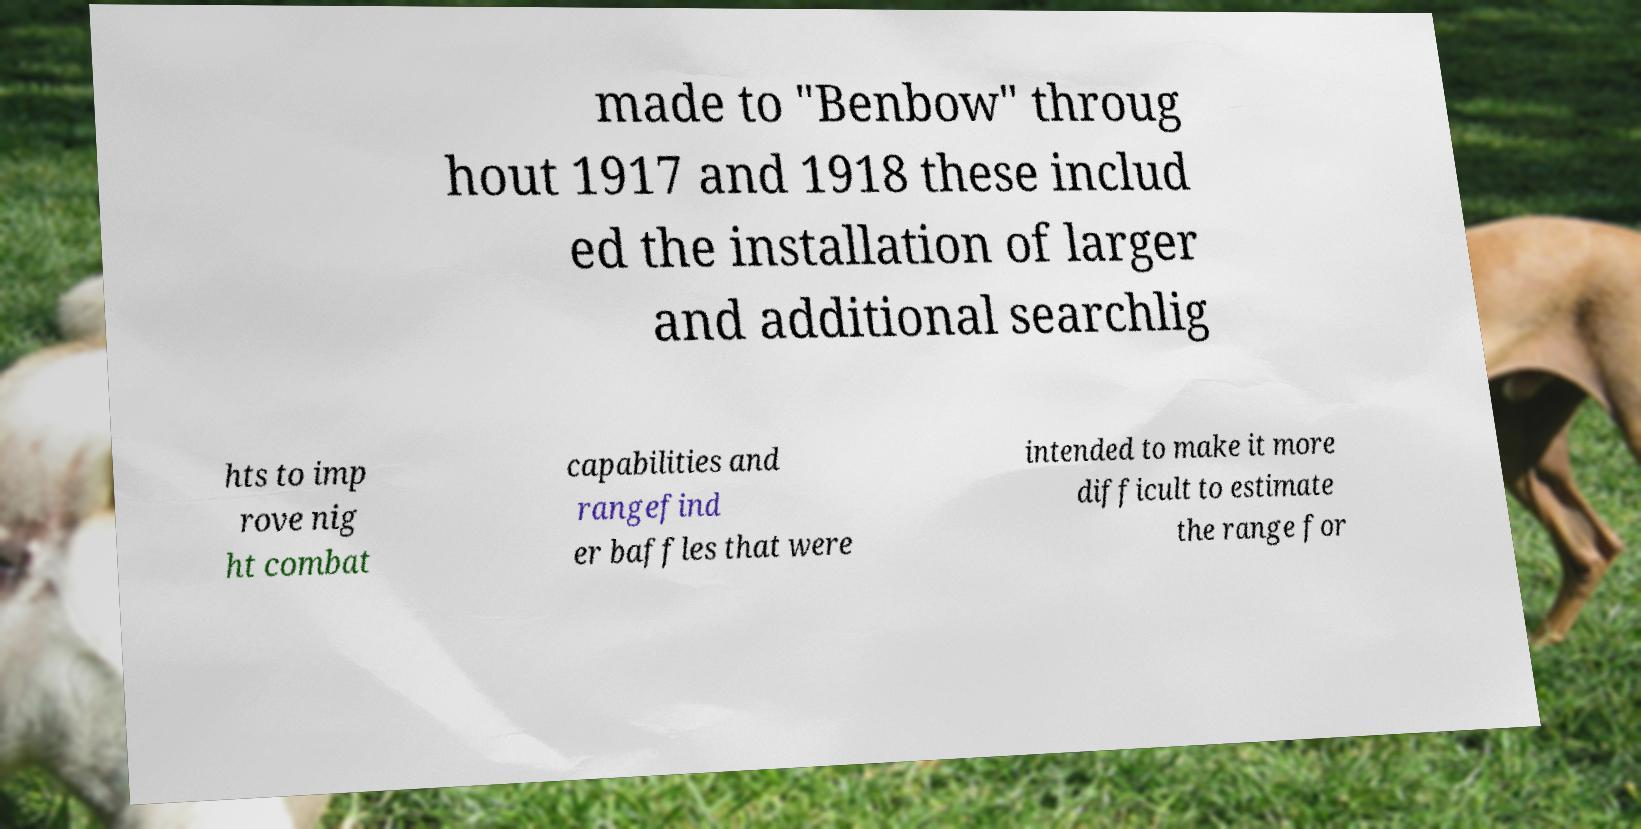What messages or text are displayed in this image? I need them in a readable, typed format. made to "Benbow" throug hout 1917 and 1918 these includ ed the installation of larger and additional searchlig hts to imp rove nig ht combat capabilities and rangefind er baffles that were intended to make it more difficult to estimate the range for 